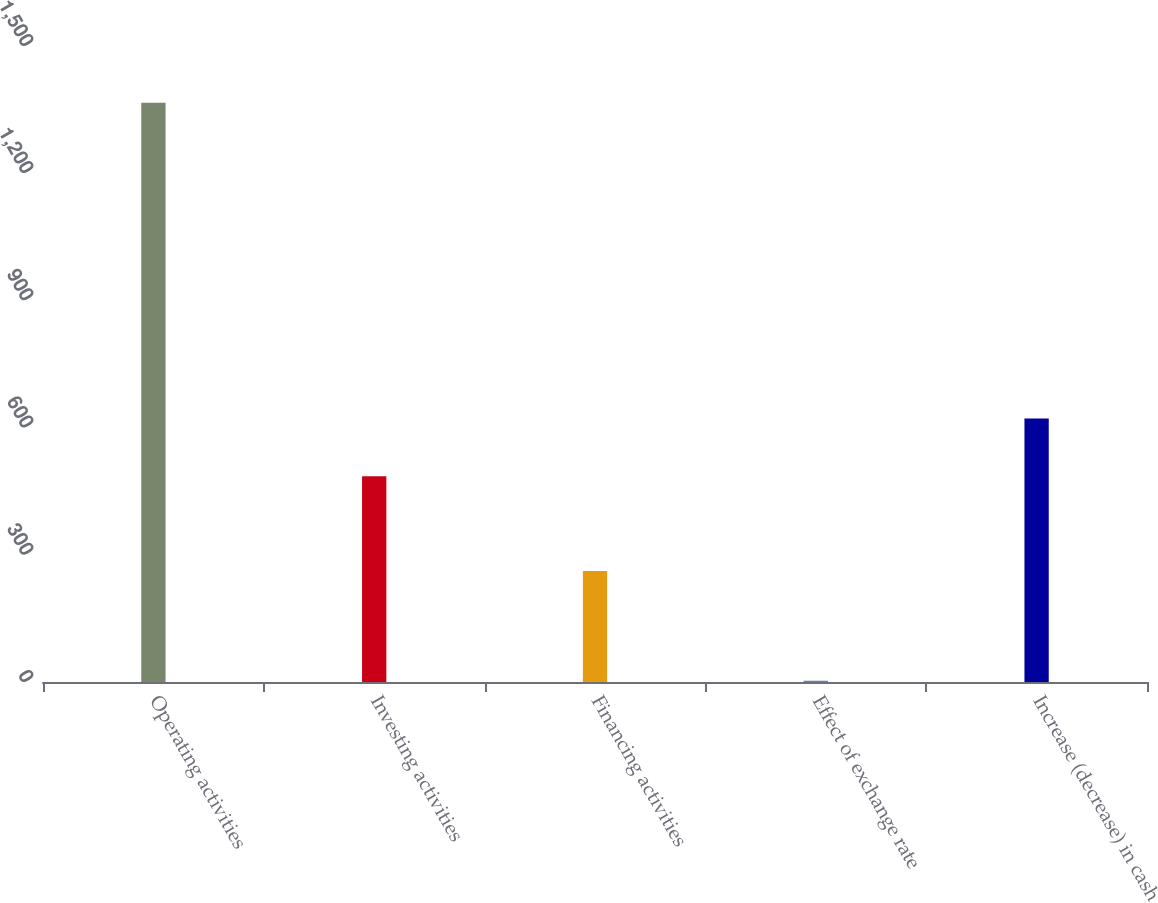Convert chart. <chart><loc_0><loc_0><loc_500><loc_500><bar_chart><fcel>Operating activities<fcel>Investing activities<fcel>Financing activities<fcel>Effect of exchange rate<fcel>Increase (decrease) in cash<nl><fcel>1366<fcel>485<fcel>262<fcel>3<fcel>621.3<nl></chart> 